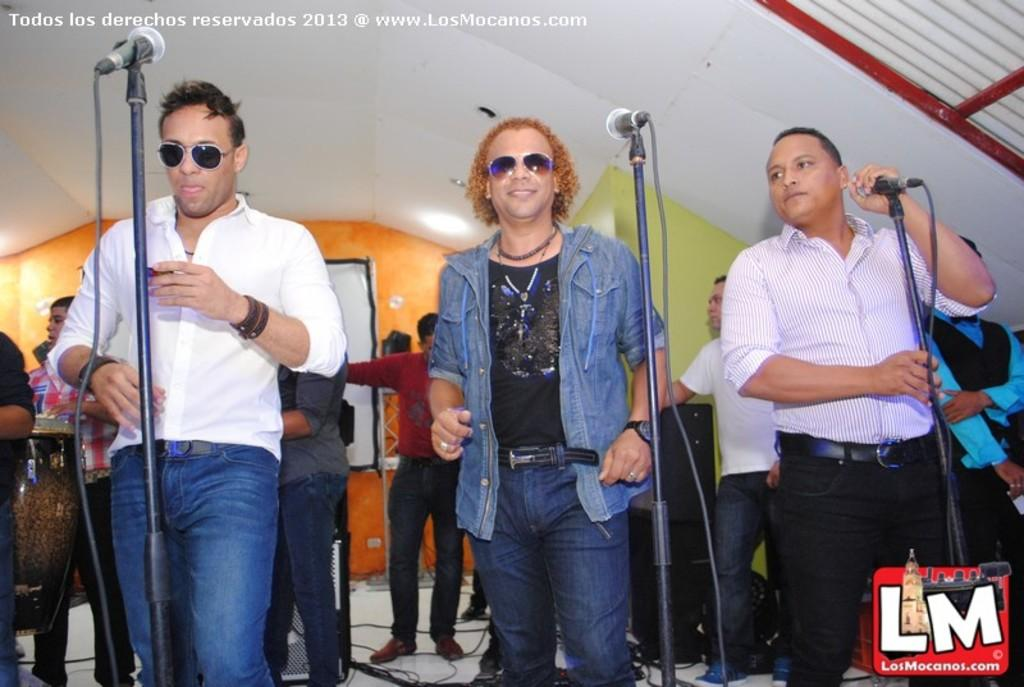How many people are in the image? There is a group of people in the image. What are some of the people in the image doing? Some people are standing, and there are three people in front of a microphone. Who is holding the microphone in the image? A man is holding a microphone in his hand. What type of horse can be seen playing a game with a spade in the image? There is no horse or game with a spade present in the image. 